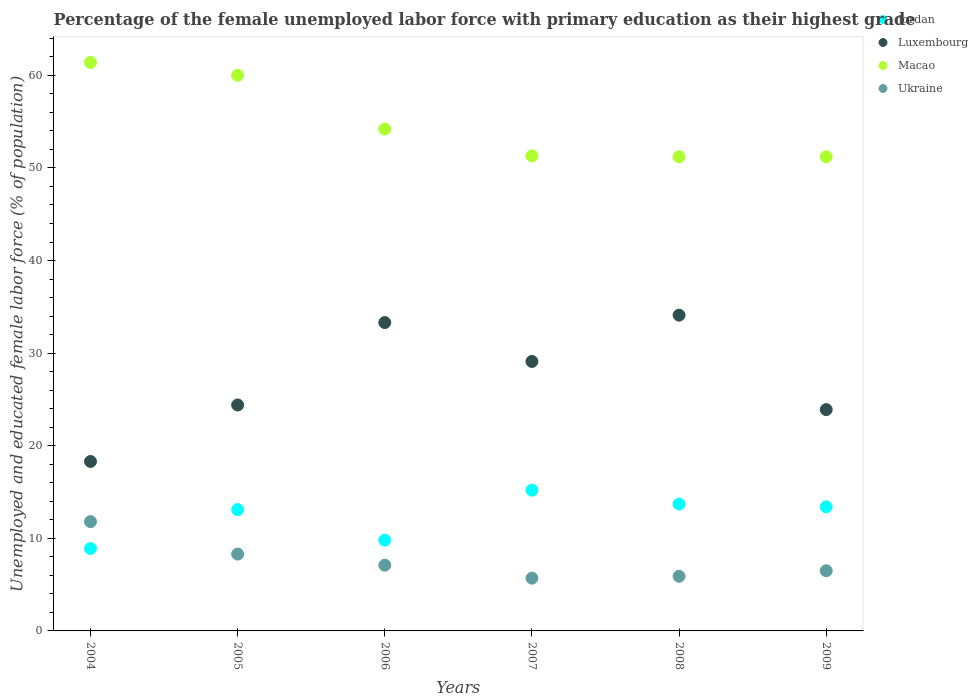How many different coloured dotlines are there?
Keep it short and to the point. 4. What is the percentage of the unemployed female labor force with primary education in Luxembourg in 2009?
Keep it short and to the point. 23.9. Across all years, what is the maximum percentage of the unemployed female labor force with primary education in Luxembourg?
Provide a short and direct response. 34.1. Across all years, what is the minimum percentage of the unemployed female labor force with primary education in Jordan?
Your answer should be very brief. 8.9. In which year was the percentage of the unemployed female labor force with primary education in Ukraine maximum?
Your answer should be very brief. 2004. In which year was the percentage of the unemployed female labor force with primary education in Ukraine minimum?
Provide a short and direct response. 2007. What is the total percentage of the unemployed female labor force with primary education in Ukraine in the graph?
Make the answer very short. 45.3. What is the difference between the percentage of the unemployed female labor force with primary education in Ukraine in 2005 and that in 2009?
Keep it short and to the point. 1.8. What is the difference between the percentage of the unemployed female labor force with primary education in Luxembourg in 2009 and the percentage of the unemployed female labor force with primary education in Ukraine in 2007?
Your answer should be compact. 18.2. What is the average percentage of the unemployed female labor force with primary education in Jordan per year?
Provide a succinct answer. 12.35. In the year 2007, what is the difference between the percentage of the unemployed female labor force with primary education in Jordan and percentage of the unemployed female labor force with primary education in Luxembourg?
Offer a very short reply. -13.9. What is the ratio of the percentage of the unemployed female labor force with primary education in Jordan in 2008 to that in 2009?
Offer a terse response. 1.02. Is the difference between the percentage of the unemployed female labor force with primary education in Jordan in 2005 and 2009 greater than the difference between the percentage of the unemployed female labor force with primary education in Luxembourg in 2005 and 2009?
Your answer should be very brief. No. What is the difference between the highest and the second highest percentage of the unemployed female labor force with primary education in Luxembourg?
Your response must be concise. 0.8. What is the difference between the highest and the lowest percentage of the unemployed female labor force with primary education in Jordan?
Give a very brief answer. 6.3. Is the sum of the percentage of the unemployed female labor force with primary education in Ukraine in 2004 and 2009 greater than the maximum percentage of the unemployed female labor force with primary education in Luxembourg across all years?
Give a very brief answer. No. Is it the case that in every year, the sum of the percentage of the unemployed female labor force with primary education in Luxembourg and percentage of the unemployed female labor force with primary education in Ukraine  is greater than the sum of percentage of the unemployed female labor force with primary education in Macao and percentage of the unemployed female labor force with primary education in Jordan?
Your answer should be very brief. No. Is the percentage of the unemployed female labor force with primary education in Luxembourg strictly greater than the percentage of the unemployed female labor force with primary education in Ukraine over the years?
Offer a terse response. Yes. Is the percentage of the unemployed female labor force with primary education in Ukraine strictly less than the percentage of the unemployed female labor force with primary education in Macao over the years?
Your answer should be compact. Yes. Does the graph contain any zero values?
Make the answer very short. No. Does the graph contain grids?
Your response must be concise. No. Where does the legend appear in the graph?
Make the answer very short. Top right. How many legend labels are there?
Provide a succinct answer. 4. How are the legend labels stacked?
Your answer should be very brief. Vertical. What is the title of the graph?
Keep it short and to the point. Percentage of the female unemployed labor force with primary education as their highest grade. Does "Qatar" appear as one of the legend labels in the graph?
Offer a terse response. No. What is the label or title of the X-axis?
Your answer should be very brief. Years. What is the label or title of the Y-axis?
Make the answer very short. Unemployed and educated female labor force (% of population). What is the Unemployed and educated female labor force (% of population) in Jordan in 2004?
Your response must be concise. 8.9. What is the Unemployed and educated female labor force (% of population) in Luxembourg in 2004?
Keep it short and to the point. 18.3. What is the Unemployed and educated female labor force (% of population) in Macao in 2004?
Your answer should be compact. 61.4. What is the Unemployed and educated female labor force (% of population) of Ukraine in 2004?
Offer a very short reply. 11.8. What is the Unemployed and educated female labor force (% of population) in Jordan in 2005?
Offer a terse response. 13.1. What is the Unemployed and educated female labor force (% of population) in Luxembourg in 2005?
Keep it short and to the point. 24.4. What is the Unemployed and educated female labor force (% of population) in Macao in 2005?
Your response must be concise. 60. What is the Unemployed and educated female labor force (% of population) in Ukraine in 2005?
Your response must be concise. 8.3. What is the Unemployed and educated female labor force (% of population) in Jordan in 2006?
Offer a terse response. 9.8. What is the Unemployed and educated female labor force (% of population) of Luxembourg in 2006?
Your answer should be compact. 33.3. What is the Unemployed and educated female labor force (% of population) of Macao in 2006?
Provide a succinct answer. 54.2. What is the Unemployed and educated female labor force (% of population) of Ukraine in 2006?
Keep it short and to the point. 7.1. What is the Unemployed and educated female labor force (% of population) in Jordan in 2007?
Your answer should be compact. 15.2. What is the Unemployed and educated female labor force (% of population) of Luxembourg in 2007?
Keep it short and to the point. 29.1. What is the Unemployed and educated female labor force (% of population) in Macao in 2007?
Make the answer very short. 51.3. What is the Unemployed and educated female labor force (% of population) in Ukraine in 2007?
Your response must be concise. 5.7. What is the Unemployed and educated female labor force (% of population) of Jordan in 2008?
Provide a succinct answer. 13.7. What is the Unemployed and educated female labor force (% of population) in Luxembourg in 2008?
Keep it short and to the point. 34.1. What is the Unemployed and educated female labor force (% of population) in Macao in 2008?
Make the answer very short. 51.2. What is the Unemployed and educated female labor force (% of population) in Ukraine in 2008?
Give a very brief answer. 5.9. What is the Unemployed and educated female labor force (% of population) of Jordan in 2009?
Keep it short and to the point. 13.4. What is the Unemployed and educated female labor force (% of population) of Luxembourg in 2009?
Make the answer very short. 23.9. What is the Unemployed and educated female labor force (% of population) of Macao in 2009?
Ensure brevity in your answer.  51.2. What is the Unemployed and educated female labor force (% of population) of Ukraine in 2009?
Your answer should be very brief. 6.5. Across all years, what is the maximum Unemployed and educated female labor force (% of population) in Jordan?
Your answer should be compact. 15.2. Across all years, what is the maximum Unemployed and educated female labor force (% of population) in Luxembourg?
Make the answer very short. 34.1. Across all years, what is the maximum Unemployed and educated female labor force (% of population) of Macao?
Provide a short and direct response. 61.4. Across all years, what is the maximum Unemployed and educated female labor force (% of population) in Ukraine?
Your answer should be very brief. 11.8. Across all years, what is the minimum Unemployed and educated female labor force (% of population) of Jordan?
Your answer should be compact. 8.9. Across all years, what is the minimum Unemployed and educated female labor force (% of population) of Luxembourg?
Keep it short and to the point. 18.3. Across all years, what is the minimum Unemployed and educated female labor force (% of population) of Macao?
Offer a very short reply. 51.2. Across all years, what is the minimum Unemployed and educated female labor force (% of population) of Ukraine?
Your answer should be very brief. 5.7. What is the total Unemployed and educated female labor force (% of population) of Jordan in the graph?
Make the answer very short. 74.1. What is the total Unemployed and educated female labor force (% of population) of Luxembourg in the graph?
Offer a terse response. 163.1. What is the total Unemployed and educated female labor force (% of population) in Macao in the graph?
Provide a short and direct response. 329.3. What is the total Unemployed and educated female labor force (% of population) of Ukraine in the graph?
Keep it short and to the point. 45.3. What is the difference between the Unemployed and educated female labor force (% of population) of Jordan in 2004 and that in 2005?
Keep it short and to the point. -4.2. What is the difference between the Unemployed and educated female labor force (% of population) in Luxembourg in 2004 and that in 2005?
Your answer should be very brief. -6.1. What is the difference between the Unemployed and educated female labor force (% of population) in Macao in 2004 and that in 2005?
Your response must be concise. 1.4. What is the difference between the Unemployed and educated female labor force (% of population) of Ukraine in 2004 and that in 2005?
Provide a short and direct response. 3.5. What is the difference between the Unemployed and educated female labor force (% of population) in Luxembourg in 2004 and that in 2007?
Make the answer very short. -10.8. What is the difference between the Unemployed and educated female labor force (% of population) of Ukraine in 2004 and that in 2007?
Ensure brevity in your answer.  6.1. What is the difference between the Unemployed and educated female labor force (% of population) of Luxembourg in 2004 and that in 2008?
Make the answer very short. -15.8. What is the difference between the Unemployed and educated female labor force (% of population) in Macao in 2004 and that in 2008?
Make the answer very short. 10.2. What is the difference between the Unemployed and educated female labor force (% of population) of Ukraine in 2004 and that in 2008?
Ensure brevity in your answer.  5.9. What is the difference between the Unemployed and educated female labor force (% of population) in Jordan in 2004 and that in 2009?
Keep it short and to the point. -4.5. What is the difference between the Unemployed and educated female labor force (% of population) in Luxembourg in 2004 and that in 2009?
Provide a succinct answer. -5.6. What is the difference between the Unemployed and educated female labor force (% of population) of Macao in 2004 and that in 2009?
Keep it short and to the point. 10.2. What is the difference between the Unemployed and educated female labor force (% of population) in Luxembourg in 2005 and that in 2006?
Make the answer very short. -8.9. What is the difference between the Unemployed and educated female labor force (% of population) of Macao in 2005 and that in 2006?
Give a very brief answer. 5.8. What is the difference between the Unemployed and educated female labor force (% of population) of Ukraine in 2005 and that in 2006?
Make the answer very short. 1.2. What is the difference between the Unemployed and educated female labor force (% of population) of Jordan in 2005 and that in 2007?
Keep it short and to the point. -2.1. What is the difference between the Unemployed and educated female labor force (% of population) of Ukraine in 2005 and that in 2007?
Your answer should be compact. 2.6. What is the difference between the Unemployed and educated female labor force (% of population) in Ukraine in 2005 and that in 2008?
Offer a terse response. 2.4. What is the difference between the Unemployed and educated female labor force (% of population) in Jordan in 2006 and that in 2007?
Your response must be concise. -5.4. What is the difference between the Unemployed and educated female labor force (% of population) in Luxembourg in 2006 and that in 2007?
Your answer should be compact. 4.2. What is the difference between the Unemployed and educated female labor force (% of population) of Macao in 2006 and that in 2007?
Your response must be concise. 2.9. What is the difference between the Unemployed and educated female labor force (% of population) of Ukraine in 2006 and that in 2007?
Ensure brevity in your answer.  1.4. What is the difference between the Unemployed and educated female labor force (% of population) in Ukraine in 2006 and that in 2008?
Give a very brief answer. 1.2. What is the difference between the Unemployed and educated female labor force (% of population) of Jordan in 2006 and that in 2009?
Ensure brevity in your answer.  -3.6. What is the difference between the Unemployed and educated female labor force (% of population) in Luxembourg in 2006 and that in 2009?
Make the answer very short. 9.4. What is the difference between the Unemployed and educated female labor force (% of population) in Macao in 2007 and that in 2008?
Make the answer very short. 0.1. What is the difference between the Unemployed and educated female labor force (% of population) of Jordan in 2008 and that in 2009?
Ensure brevity in your answer.  0.3. What is the difference between the Unemployed and educated female labor force (% of population) of Luxembourg in 2008 and that in 2009?
Your answer should be very brief. 10.2. What is the difference between the Unemployed and educated female labor force (% of population) of Ukraine in 2008 and that in 2009?
Offer a terse response. -0.6. What is the difference between the Unemployed and educated female labor force (% of population) of Jordan in 2004 and the Unemployed and educated female labor force (% of population) of Luxembourg in 2005?
Your response must be concise. -15.5. What is the difference between the Unemployed and educated female labor force (% of population) of Jordan in 2004 and the Unemployed and educated female labor force (% of population) of Macao in 2005?
Give a very brief answer. -51.1. What is the difference between the Unemployed and educated female labor force (% of population) in Luxembourg in 2004 and the Unemployed and educated female labor force (% of population) in Macao in 2005?
Offer a terse response. -41.7. What is the difference between the Unemployed and educated female labor force (% of population) of Luxembourg in 2004 and the Unemployed and educated female labor force (% of population) of Ukraine in 2005?
Keep it short and to the point. 10. What is the difference between the Unemployed and educated female labor force (% of population) of Macao in 2004 and the Unemployed and educated female labor force (% of population) of Ukraine in 2005?
Offer a very short reply. 53.1. What is the difference between the Unemployed and educated female labor force (% of population) in Jordan in 2004 and the Unemployed and educated female labor force (% of population) in Luxembourg in 2006?
Offer a terse response. -24.4. What is the difference between the Unemployed and educated female labor force (% of population) in Jordan in 2004 and the Unemployed and educated female labor force (% of population) in Macao in 2006?
Make the answer very short. -45.3. What is the difference between the Unemployed and educated female labor force (% of population) of Jordan in 2004 and the Unemployed and educated female labor force (% of population) of Ukraine in 2006?
Keep it short and to the point. 1.8. What is the difference between the Unemployed and educated female labor force (% of population) in Luxembourg in 2004 and the Unemployed and educated female labor force (% of population) in Macao in 2006?
Your answer should be compact. -35.9. What is the difference between the Unemployed and educated female labor force (% of population) of Luxembourg in 2004 and the Unemployed and educated female labor force (% of population) of Ukraine in 2006?
Ensure brevity in your answer.  11.2. What is the difference between the Unemployed and educated female labor force (% of population) of Macao in 2004 and the Unemployed and educated female labor force (% of population) of Ukraine in 2006?
Keep it short and to the point. 54.3. What is the difference between the Unemployed and educated female labor force (% of population) in Jordan in 2004 and the Unemployed and educated female labor force (% of population) in Luxembourg in 2007?
Give a very brief answer. -20.2. What is the difference between the Unemployed and educated female labor force (% of population) in Jordan in 2004 and the Unemployed and educated female labor force (% of population) in Macao in 2007?
Keep it short and to the point. -42.4. What is the difference between the Unemployed and educated female labor force (% of population) of Jordan in 2004 and the Unemployed and educated female labor force (% of population) of Ukraine in 2007?
Provide a succinct answer. 3.2. What is the difference between the Unemployed and educated female labor force (% of population) of Luxembourg in 2004 and the Unemployed and educated female labor force (% of population) of Macao in 2007?
Your answer should be very brief. -33. What is the difference between the Unemployed and educated female labor force (% of population) in Luxembourg in 2004 and the Unemployed and educated female labor force (% of population) in Ukraine in 2007?
Ensure brevity in your answer.  12.6. What is the difference between the Unemployed and educated female labor force (% of population) of Macao in 2004 and the Unemployed and educated female labor force (% of population) of Ukraine in 2007?
Offer a terse response. 55.7. What is the difference between the Unemployed and educated female labor force (% of population) of Jordan in 2004 and the Unemployed and educated female labor force (% of population) of Luxembourg in 2008?
Give a very brief answer. -25.2. What is the difference between the Unemployed and educated female labor force (% of population) in Jordan in 2004 and the Unemployed and educated female labor force (% of population) in Macao in 2008?
Provide a succinct answer. -42.3. What is the difference between the Unemployed and educated female labor force (% of population) in Luxembourg in 2004 and the Unemployed and educated female labor force (% of population) in Macao in 2008?
Offer a very short reply. -32.9. What is the difference between the Unemployed and educated female labor force (% of population) in Macao in 2004 and the Unemployed and educated female labor force (% of population) in Ukraine in 2008?
Provide a short and direct response. 55.5. What is the difference between the Unemployed and educated female labor force (% of population) of Jordan in 2004 and the Unemployed and educated female labor force (% of population) of Macao in 2009?
Provide a short and direct response. -42.3. What is the difference between the Unemployed and educated female labor force (% of population) of Jordan in 2004 and the Unemployed and educated female labor force (% of population) of Ukraine in 2009?
Provide a succinct answer. 2.4. What is the difference between the Unemployed and educated female labor force (% of population) in Luxembourg in 2004 and the Unemployed and educated female labor force (% of population) in Macao in 2009?
Make the answer very short. -32.9. What is the difference between the Unemployed and educated female labor force (% of population) of Macao in 2004 and the Unemployed and educated female labor force (% of population) of Ukraine in 2009?
Give a very brief answer. 54.9. What is the difference between the Unemployed and educated female labor force (% of population) in Jordan in 2005 and the Unemployed and educated female labor force (% of population) in Luxembourg in 2006?
Offer a terse response. -20.2. What is the difference between the Unemployed and educated female labor force (% of population) of Jordan in 2005 and the Unemployed and educated female labor force (% of population) of Macao in 2006?
Offer a very short reply. -41.1. What is the difference between the Unemployed and educated female labor force (% of population) of Jordan in 2005 and the Unemployed and educated female labor force (% of population) of Ukraine in 2006?
Your answer should be compact. 6. What is the difference between the Unemployed and educated female labor force (% of population) of Luxembourg in 2005 and the Unemployed and educated female labor force (% of population) of Macao in 2006?
Offer a terse response. -29.8. What is the difference between the Unemployed and educated female labor force (% of population) of Luxembourg in 2005 and the Unemployed and educated female labor force (% of population) of Ukraine in 2006?
Offer a very short reply. 17.3. What is the difference between the Unemployed and educated female labor force (% of population) of Macao in 2005 and the Unemployed and educated female labor force (% of population) of Ukraine in 2006?
Ensure brevity in your answer.  52.9. What is the difference between the Unemployed and educated female labor force (% of population) in Jordan in 2005 and the Unemployed and educated female labor force (% of population) in Luxembourg in 2007?
Your answer should be compact. -16. What is the difference between the Unemployed and educated female labor force (% of population) in Jordan in 2005 and the Unemployed and educated female labor force (% of population) in Macao in 2007?
Offer a very short reply. -38.2. What is the difference between the Unemployed and educated female labor force (% of population) in Luxembourg in 2005 and the Unemployed and educated female labor force (% of population) in Macao in 2007?
Offer a terse response. -26.9. What is the difference between the Unemployed and educated female labor force (% of population) of Luxembourg in 2005 and the Unemployed and educated female labor force (% of population) of Ukraine in 2007?
Your response must be concise. 18.7. What is the difference between the Unemployed and educated female labor force (% of population) in Macao in 2005 and the Unemployed and educated female labor force (% of population) in Ukraine in 2007?
Provide a short and direct response. 54.3. What is the difference between the Unemployed and educated female labor force (% of population) of Jordan in 2005 and the Unemployed and educated female labor force (% of population) of Luxembourg in 2008?
Provide a succinct answer. -21. What is the difference between the Unemployed and educated female labor force (% of population) in Jordan in 2005 and the Unemployed and educated female labor force (% of population) in Macao in 2008?
Your response must be concise. -38.1. What is the difference between the Unemployed and educated female labor force (% of population) in Jordan in 2005 and the Unemployed and educated female labor force (% of population) in Ukraine in 2008?
Provide a short and direct response. 7.2. What is the difference between the Unemployed and educated female labor force (% of population) in Luxembourg in 2005 and the Unemployed and educated female labor force (% of population) in Macao in 2008?
Provide a short and direct response. -26.8. What is the difference between the Unemployed and educated female labor force (% of population) of Macao in 2005 and the Unemployed and educated female labor force (% of population) of Ukraine in 2008?
Your answer should be compact. 54.1. What is the difference between the Unemployed and educated female labor force (% of population) of Jordan in 2005 and the Unemployed and educated female labor force (% of population) of Luxembourg in 2009?
Give a very brief answer. -10.8. What is the difference between the Unemployed and educated female labor force (% of population) in Jordan in 2005 and the Unemployed and educated female labor force (% of population) in Macao in 2009?
Give a very brief answer. -38.1. What is the difference between the Unemployed and educated female labor force (% of population) of Luxembourg in 2005 and the Unemployed and educated female labor force (% of population) of Macao in 2009?
Make the answer very short. -26.8. What is the difference between the Unemployed and educated female labor force (% of population) in Luxembourg in 2005 and the Unemployed and educated female labor force (% of population) in Ukraine in 2009?
Make the answer very short. 17.9. What is the difference between the Unemployed and educated female labor force (% of population) of Macao in 2005 and the Unemployed and educated female labor force (% of population) of Ukraine in 2009?
Provide a succinct answer. 53.5. What is the difference between the Unemployed and educated female labor force (% of population) of Jordan in 2006 and the Unemployed and educated female labor force (% of population) of Luxembourg in 2007?
Your answer should be very brief. -19.3. What is the difference between the Unemployed and educated female labor force (% of population) in Jordan in 2006 and the Unemployed and educated female labor force (% of population) in Macao in 2007?
Your answer should be very brief. -41.5. What is the difference between the Unemployed and educated female labor force (% of population) of Jordan in 2006 and the Unemployed and educated female labor force (% of population) of Ukraine in 2007?
Ensure brevity in your answer.  4.1. What is the difference between the Unemployed and educated female labor force (% of population) in Luxembourg in 2006 and the Unemployed and educated female labor force (% of population) in Macao in 2007?
Make the answer very short. -18. What is the difference between the Unemployed and educated female labor force (% of population) in Luxembourg in 2006 and the Unemployed and educated female labor force (% of population) in Ukraine in 2007?
Provide a succinct answer. 27.6. What is the difference between the Unemployed and educated female labor force (% of population) in Macao in 2006 and the Unemployed and educated female labor force (% of population) in Ukraine in 2007?
Ensure brevity in your answer.  48.5. What is the difference between the Unemployed and educated female labor force (% of population) in Jordan in 2006 and the Unemployed and educated female labor force (% of population) in Luxembourg in 2008?
Offer a very short reply. -24.3. What is the difference between the Unemployed and educated female labor force (% of population) of Jordan in 2006 and the Unemployed and educated female labor force (% of population) of Macao in 2008?
Offer a terse response. -41.4. What is the difference between the Unemployed and educated female labor force (% of population) of Luxembourg in 2006 and the Unemployed and educated female labor force (% of population) of Macao in 2008?
Provide a short and direct response. -17.9. What is the difference between the Unemployed and educated female labor force (% of population) of Luxembourg in 2006 and the Unemployed and educated female labor force (% of population) of Ukraine in 2008?
Give a very brief answer. 27.4. What is the difference between the Unemployed and educated female labor force (% of population) in Macao in 2006 and the Unemployed and educated female labor force (% of population) in Ukraine in 2008?
Provide a succinct answer. 48.3. What is the difference between the Unemployed and educated female labor force (% of population) in Jordan in 2006 and the Unemployed and educated female labor force (% of population) in Luxembourg in 2009?
Ensure brevity in your answer.  -14.1. What is the difference between the Unemployed and educated female labor force (% of population) in Jordan in 2006 and the Unemployed and educated female labor force (% of population) in Macao in 2009?
Provide a short and direct response. -41.4. What is the difference between the Unemployed and educated female labor force (% of population) of Jordan in 2006 and the Unemployed and educated female labor force (% of population) of Ukraine in 2009?
Your answer should be compact. 3.3. What is the difference between the Unemployed and educated female labor force (% of population) of Luxembourg in 2006 and the Unemployed and educated female labor force (% of population) of Macao in 2009?
Offer a very short reply. -17.9. What is the difference between the Unemployed and educated female labor force (% of population) in Luxembourg in 2006 and the Unemployed and educated female labor force (% of population) in Ukraine in 2009?
Keep it short and to the point. 26.8. What is the difference between the Unemployed and educated female labor force (% of population) of Macao in 2006 and the Unemployed and educated female labor force (% of population) of Ukraine in 2009?
Provide a short and direct response. 47.7. What is the difference between the Unemployed and educated female labor force (% of population) in Jordan in 2007 and the Unemployed and educated female labor force (% of population) in Luxembourg in 2008?
Provide a short and direct response. -18.9. What is the difference between the Unemployed and educated female labor force (% of population) in Jordan in 2007 and the Unemployed and educated female labor force (% of population) in Macao in 2008?
Provide a succinct answer. -36. What is the difference between the Unemployed and educated female labor force (% of population) in Luxembourg in 2007 and the Unemployed and educated female labor force (% of population) in Macao in 2008?
Your response must be concise. -22.1. What is the difference between the Unemployed and educated female labor force (% of population) in Luxembourg in 2007 and the Unemployed and educated female labor force (% of population) in Ukraine in 2008?
Keep it short and to the point. 23.2. What is the difference between the Unemployed and educated female labor force (% of population) of Macao in 2007 and the Unemployed and educated female labor force (% of population) of Ukraine in 2008?
Ensure brevity in your answer.  45.4. What is the difference between the Unemployed and educated female labor force (% of population) in Jordan in 2007 and the Unemployed and educated female labor force (% of population) in Luxembourg in 2009?
Your answer should be very brief. -8.7. What is the difference between the Unemployed and educated female labor force (% of population) of Jordan in 2007 and the Unemployed and educated female labor force (% of population) of Macao in 2009?
Keep it short and to the point. -36. What is the difference between the Unemployed and educated female labor force (% of population) of Jordan in 2007 and the Unemployed and educated female labor force (% of population) of Ukraine in 2009?
Provide a succinct answer. 8.7. What is the difference between the Unemployed and educated female labor force (% of population) in Luxembourg in 2007 and the Unemployed and educated female labor force (% of population) in Macao in 2009?
Your response must be concise. -22.1. What is the difference between the Unemployed and educated female labor force (% of population) in Luxembourg in 2007 and the Unemployed and educated female labor force (% of population) in Ukraine in 2009?
Give a very brief answer. 22.6. What is the difference between the Unemployed and educated female labor force (% of population) in Macao in 2007 and the Unemployed and educated female labor force (% of population) in Ukraine in 2009?
Offer a terse response. 44.8. What is the difference between the Unemployed and educated female labor force (% of population) in Jordan in 2008 and the Unemployed and educated female labor force (% of population) in Luxembourg in 2009?
Offer a terse response. -10.2. What is the difference between the Unemployed and educated female labor force (% of population) in Jordan in 2008 and the Unemployed and educated female labor force (% of population) in Macao in 2009?
Give a very brief answer. -37.5. What is the difference between the Unemployed and educated female labor force (% of population) in Jordan in 2008 and the Unemployed and educated female labor force (% of population) in Ukraine in 2009?
Your answer should be very brief. 7.2. What is the difference between the Unemployed and educated female labor force (% of population) of Luxembourg in 2008 and the Unemployed and educated female labor force (% of population) of Macao in 2009?
Offer a terse response. -17.1. What is the difference between the Unemployed and educated female labor force (% of population) in Luxembourg in 2008 and the Unemployed and educated female labor force (% of population) in Ukraine in 2009?
Provide a short and direct response. 27.6. What is the difference between the Unemployed and educated female labor force (% of population) of Macao in 2008 and the Unemployed and educated female labor force (% of population) of Ukraine in 2009?
Offer a terse response. 44.7. What is the average Unemployed and educated female labor force (% of population) of Jordan per year?
Make the answer very short. 12.35. What is the average Unemployed and educated female labor force (% of population) of Luxembourg per year?
Provide a succinct answer. 27.18. What is the average Unemployed and educated female labor force (% of population) of Macao per year?
Keep it short and to the point. 54.88. What is the average Unemployed and educated female labor force (% of population) of Ukraine per year?
Ensure brevity in your answer.  7.55. In the year 2004, what is the difference between the Unemployed and educated female labor force (% of population) in Jordan and Unemployed and educated female labor force (% of population) in Luxembourg?
Your response must be concise. -9.4. In the year 2004, what is the difference between the Unemployed and educated female labor force (% of population) in Jordan and Unemployed and educated female labor force (% of population) in Macao?
Your response must be concise. -52.5. In the year 2004, what is the difference between the Unemployed and educated female labor force (% of population) of Jordan and Unemployed and educated female labor force (% of population) of Ukraine?
Make the answer very short. -2.9. In the year 2004, what is the difference between the Unemployed and educated female labor force (% of population) of Luxembourg and Unemployed and educated female labor force (% of population) of Macao?
Give a very brief answer. -43.1. In the year 2004, what is the difference between the Unemployed and educated female labor force (% of population) of Macao and Unemployed and educated female labor force (% of population) of Ukraine?
Your answer should be very brief. 49.6. In the year 2005, what is the difference between the Unemployed and educated female labor force (% of population) of Jordan and Unemployed and educated female labor force (% of population) of Luxembourg?
Provide a short and direct response. -11.3. In the year 2005, what is the difference between the Unemployed and educated female labor force (% of population) in Jordan and Unemployed and educated female labor force (% of population) in Macao?
Offer a terse response. -46.9. In the year 2005, what is the difference between the Unemployed and educated female labor force (% of population) in Jordan and Unemployed and educated female labor force (% of population) in Ukraine?
Offer a terse response. 4.8. In the year 2005, what is the difference between the Unemployed and educated female labor force (% of population) of Luxembourg and Unemployed and educated female labor force (% of population) of Macao?
Your answer should be compact. -35.6. In the year 2005, what is the difference between the Unemployed and educated female labor force (% of population) of Luxembourg and Unemployed and educated female labor force (% of population) of Ukraine?
Ensure brevity in your answer.  16.1. In the year 2005, what is the difference between the Unemployed and educated female labor force (% of population) in Macao and Unemployed and educated female labor force (% of population) in Ukraine?
Offer a very short reply. 51.7. In the year 2006, what is the difference between the Unemployed and educated female labor force (% of population) of Jordan and Unemployed and educated female labor force (% of population) of Luxembourg?
Your answer should be compact. -23.5. In the year 2006, what is the difference between the Unemployed and educated female labor force (% of population) in Jordan and Unemployed and educated female labor force (% of population) in Macao?
Your response must be concise. -44.4. In the year 2006, what is the difference between the Unemployed and educated female labor force (% of population) in Jordan and Unemployed and educated female labor force (% of population) in Ukraine?
Provide a succinct answer. 2.7. In the year 2006, what is the difference between the Unemployed and educated female labor force (% of population) in Luxembourg and Unemployed and educated female labor force (% of population) in Macao?
Your response must be concise. -20.9. In the year 2006, what is the difference between the Unemployed and educated female labor force (% of population) of Luxembourg and Unemployed and educated female labor force (% of population) of Ukraine?
Provide a succinct answer. 26.2. In the year 2006, what is the difference between the Unemployed and educated female labor force (% of population) of Macao and Unemployed and educated female labor force (% of population) of Ukraine?
Your answer should be compact. 47.1. In the year 2007, what is the difference between the Unemployed and educated female labor force (% of population) in Jordan and Unemployed and educated female labor force (% of population) in Macao?
Keep it short and to the point. -36.1. In the year 2007, what is the difference between the Unemployed and educated female labor force (% of population) in Luxembourg and Unemployed and educated female labor force (% of population) in Macao?
Your answer should be compact. -22.2. In the year 2007, what is the difference between the Unemployed and educated female labor force (% of population) of Luxembourg and Unemployed and educated female labor force (% of population) of Ukraine?
Give a very brief answer. 23.4. In the year 2007, what is the difference between the Unemployed and educated female labor force (% of population) in Macao and Unemployed and educated female labor force (% of population) in Ukraine?
Offer a terse response. 45.6. In the year 2008, what is the difference between the Unemployed and educated female labor force (% of population) in Jordan and Unemployed and educated female labor force (% of population) in Luxembourg?
Provide a succinct answer. -20.4. In the year 2008, what is the difference between the Unemployed and educated female labor force (% of population) of Jordan and Unemployed and educated female labor force (% of population) of Macao?
Ensure brevity in your answer.  -37.5. In the year 2008, what is the difference between the Unemployed and educated female labor force (% of population) of Jordan and Unemployed and educated female labor force (% of population) of Ukraine?
Provide a succinct answer. 7.8. In the year 2008, what is the difference between the Unemployed and educated female labor force (% of population) of Luxembourg and Unemployed and educated female labor force (% of population) of Macao?
Make the answer very short. -17.1. In the year 2008, what is the difference between the Unemployed and educated female labor force (% of population) of Luxembourg and Unemployed and educated female labor force (% of population) of Ukraine?
Offer a very short reply. 28.2. In the year 2008, what is the difference between the Unemployed and educated female labor force (% of population) of Macao and Unemployed and educated female labor force (% of population) of Ukraine?
Your response must be concise. 45.3. In the year 2009, what is the difference between the Unemployed and educated female labor force (% of population) of Jordan and Unemployed and educated female labor force (% of population) of Luxembourg?
Provide a succinct answer. -10.5. In the year 2009, what is the difference between the Unemployed and educated female labor force (% of population) in Jordan and Unemployed and educated female labor force (% of population) in Macao?
Offer a terse response. -37.8. In the year 2009, what is the difference between the Unemployed and educated female labor force (% of population) in Luxembourg and Unemployed and educated female labor force (% of population) in Macao?
Your response must be concise. -27.3. In the year 2009, what is the difference between the Unemployed and educated female labor force (% of population) in Macao and Unemployed and educated female labor force (% of population) in Ukraine?
Provide a succinct answer. 44.7. What is the ratio of the Unemployed and educated female labor force (% of population) in Jordan in 2004 to that in 2005?
Provide a succinct answer. 0.68. What is the ratio of the Unemployed and educated female labor force (% of population) of Luxembourg in 2004 to that in 2005?
Provide a short and direct response. 0.75. What is the ratio of the Unemployed and educated female labor force (% of population) of Macao in 2004 to that in 2005?
Offer a very short reply. 1.02. What is the ratio of the Unemployed and educated female labor force (% of population) in Ukraine in 2004 to that in 2005?
Keep it short and to the point. 1.42. What is the ratio of the Unemployed and educated female labor force (% of population) of Jordan in 2004 to that in 2006?
Give a very brief answer. 0.91. What is the ratio of the Unemployed and educated female labor force (% of population) of Luxembourg in 2004 to that in 2006?
Make the answer very short. 0.55. What is the ratio of the Unemployed and educated female labor force (% of population) of Macao in 2004 to that in 2006?
Provide a succinct answer. 1.13. What is the ratio of the Unemployed and educated female labor force (% of population) in Ukraine in 2004 to that in 2006?
Offer a very short reply. 1.66. What is the ratio of the Unemployed and educated female labor force (% of population) of Jordan in 2004 to that in 2007?
Your answer should be very brief. 0.59. What is the ratio of the Unemployed and educated female labor force (% of population) in Luxembourg in 2004 to that in 2007?
Provide a succinct answer. 0.63. What is the ratio of the Unemployed and educated female labor force (% of population) in Macao in 2004 to that in 2007?
Give a very brief answer. 1.2. What is the ratio of the Unemployed and educated female labor force (% of population) of Ukraine in 2004 to that in 2007?
Your response must be concise. 2.07. What is the ratio of the Unemployed and educated female labor force (% of population) in Jordan in 2004 to that in 2008?
Offer a terse response. 0.65. What is the ratio of the Unemployed and educated female labor force (% of population) of Luxembourg in 2004 to that in 2008?
Your answer should be very brief. 0.54. What is the ratio of the Unemployed and educated female labor force (% of population) in Macao in 2004 to that in 2008?
Make the answer very short. 1.2. What is the ratio of the Unemployed and educated female labor force (% of population) in Jordan in 2004 to that in 2009?
Make the answer very short. 0.66. What is the ratio of the Unemployed and educated female labor force (% of population) in Luxembourg in 2004 to that in 2009?
Your answer should be very brief. 0.77. What is the ratio of the Unemployed and educated female labor force (% of population) in Macao in 2004 to that in 2009?
Your response must be concise. 1.2. What is the ratio of the Unemployed and educated female labor force (% of population) in Ukraine in 2004 to that in 2009?
Your answer should be very brief. 1.82. What is the ratio of the Unemployed and educated female labor force (% of population) in Jordan in 2005 to that in 2006?
Offer a very short reply. 1.34. What is the ratio of the Unemployed and educated female labor force (% of population) of Luxembourg in 2005 to that in 2006?
Offer a very short reply. 0.73. What is the ratio of the Unemployed and educated female labor force (% of population) of Macao in 2005 to that in 2006?
Give a very brief answer. 1.11. What is the ratio of the Unemployed and educated female labor force (% of population) of Ukraine in 2005 to that in 2006?
Make the answer very short. 1.17. What is the ratio of the Unemployed and educated female labor force (% of population) of Jordan in 2005 to that in 2007?
Keep it short and to the point. 0.86. What is the ratio of the Unemployed and educated female labor force (% of population) of Luxembourg in 2005 to that in 2007?
Make the answer very short. 0.84. What is the ratio of the Unemployed and educated female labor force (% of population) of Macao in 2005 to that in 2007?
Give a very brief answer. 1.17. What is the ratio of the Unemployed and educated female labor force (% of population) in Ukraine in 2005 to that in 2007?
Your answer should be compact. 1.46. What is the ratio of the Unemployed and educated female labor force (% of population) of Jordan in 2005 to that in 2008?
Make the answer very short. 0.96. What is the ratio of the Unemployed and educated female labor force (% of population) in Luxembourg in 2005 to that in 2008?
Keep it short and to the point. 0.72. What is the ratio of the Unemployed and educated female labor force (% of population) in Macao in 2005 to that in 2008?
Offer a very short reply. 1.17. What is the ratio of the Unemployed and educated female labor force (% of population) in Ukraine in 2005 to that in 2008?
Make the answer very short. 1.41. What is the ratio of the Unemployed and educated female labor force (% of population) in Jordan in 2005 to that in 2009?
Provide a succinct answer. 0.98. What is the ratio of the Unemployed and educated female labor force (% of population) in Luxembourg in 2005 to that in 2009?
Ensure brevity in your answer.  1.02. What is the ratio of the Unemployed and educated female labor force (% of population) of Macao in 2005 to that in 2009?
Offer a very short reply. 1.17. What is the ratio of the Unemployed and educated female labor force (% of population) of Ukraine in 2005 to that in 2009?
Your answer should be compact. 1.28. What is the ratio of the Unemployed and educated female labor force (% of population) of Jordan in 2006 to that in 2007?
Offer a very short reply. 0.64. What is the ratio of the Unemployed and educated female labor force (% of population) in Luxembourg in 2006 to that in 2007?
Offer a very short reply. 1.14. What is the ratio of the Unemployed and educated female labor force (% of population) of Macao in 2006 to that in 2007?
Provide a succinct answer. 1.06. What is the ratio of the Unemployed and educated female labor force (% of population) of Ukraine in 2006 to that in 2007?
Keep it short and to the point. 1.25. What is the ratio of the Unemployed and educated female labor force (% of population) of Jordan in 2006 to that in 2008?
Provide a succinct answer. 0.72. What is the ratio of the Unemployed and educated female labor force (% of population) in Luxembourg in 2006 to that in 2008?
Provide a short and direct response. 0.98. What is the ratio of the Unemployed and educated female labor force (% of population) of Macao in 2006 to that in 2008?
Your response must be concise. 1.06. What is the ratio of the Unemployed and educated female labor force (% of population) in Ukraine in 2006 to that in 2008?
Provide a short and direct response. 1.2. What is the ratio of the Unemployed and educated female labor force (% of population) in Jordan in 2006 to that in 2009?
Your answer should be very brief. 0.73. What is the ratio of the Unemployed and educated female labor force (% of population) of Luxembourg in 2006 to that in 2009?
Your response must be concise. 1.39. What is the ratio of the Unemployed and educated female labor force (% of population) of Macao in 2006 to that in 2009?
Ensure brevity in your answer.  1.06. What is the ratio of the Unemployed and educated female labor force (% of population) in Ukraine in 2006 to that in 2009?
Your answer should be very brief. 1.09. What is the ratio of the Unemployed and educated female labor force (% of population) of Jordan in 2007 to that in 2008?
Your response must be concise. 1.11. What is the ratio of the Unemployed and educated female labor force (% of population) of Luxembourg in 2007 to that in 2008?
Provide a succinct answer. 0.85. What is the ratio of the Unemployed and educated female labor force (% of population) of Ukraine in 2007 to that in 2008?
Provide a short and direct response. 0.97. What is the ratio of the Unemployed and educated female labor force (% of population) of Jordan in 2007 to that in 2009?
Keep it short and to the point. 1.13. What is the ratio of the Unemployed and educated female labor force (% of population) in Luxembourg in 2007 to that in 2009?
Offer a terse response. 1.22. What is the ratio of the Unemployed and educated female labor force (% of population) of Macao in 2007 to that in 2009?
Provide a short and direct response. 1. What is the ratio of the Unemployed and educated female labor force (% of population) of Ukraine in 2007 to that in 2009?
Your answer should be very brief. 0.88. What is the ratio of the Unemployed and educated female labor force (% of population) in Jordan in 2008 to that in 2009?
Your response must be concise. 1.02. What is the ratio of the Unemployed and educated female labor force (% of population) in Luxembourg in 2008 to that in 2009?
Provide a short and direct response. 1.43. What is the ratio of the Unemployed and educated female labor force (% of population) of Macao in 2008 to that in 2009?
Ensure brevity in your answer.  1. What is the ratio of the Unemployed and educated female labor force (% of population) in Ukraine in 2008 to that in 2009?
Your response must be concise. 0.91. What is the difference between the highest and the second highest Unemployed and educated female labor force (% of population) of Luxembourg?
Offer a very short reply. 0.8. What is the difference between the highest and the lowest Unemployed and educated female labor force (% of population) in Luxembourg?
Offer a very short reply. 15.8. 